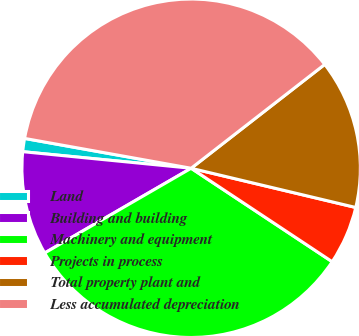Convert chart to OTSL. <chart><loc_0><loc_0><loc_500><loc_500><pie_chart><fcel>Land<fcel>Building and building<fcel>Machinery and equipment<fcel>Projects in process<fcel>Total property plant and<fcel>Less accumulated depreciation<nl><fcel>1.26%<fcel>9.91%<fcel>32.34%<fcel>5.59%<fcel>14.24%<fcel>36.66%<nl></chart> 